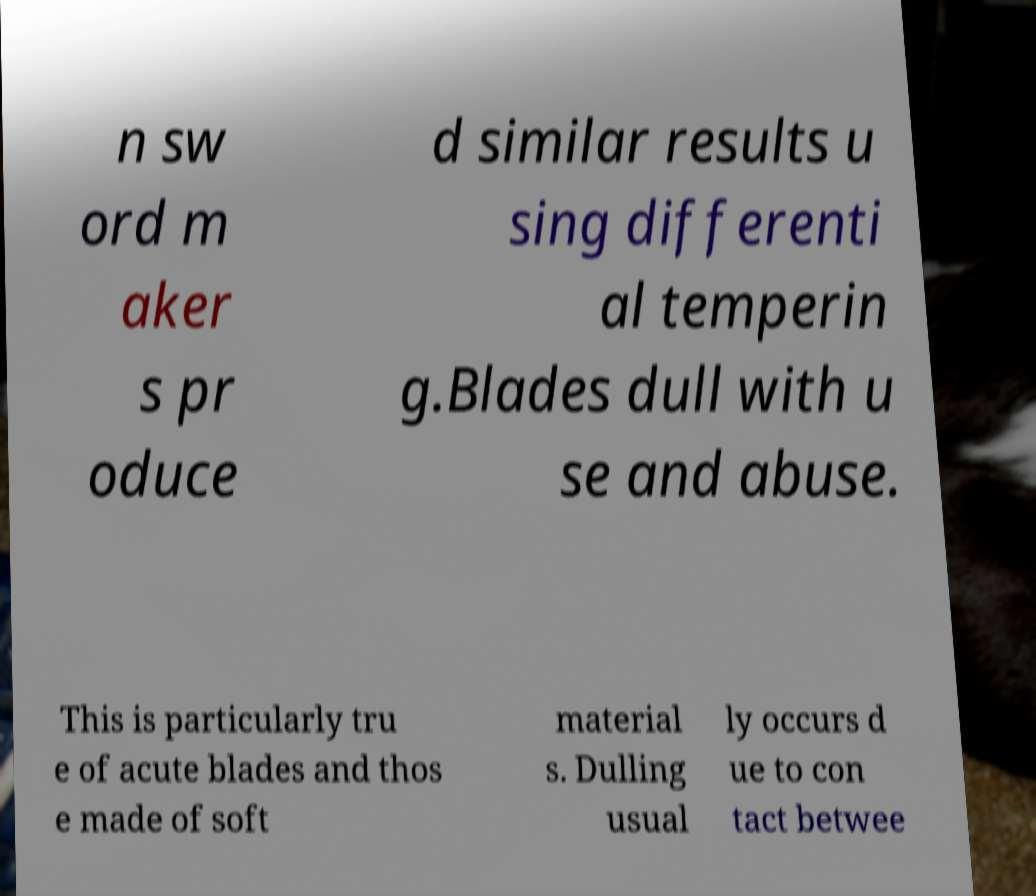Please identify and transcribe the text found in this image. n sw ord m aker s pr oduce d similar results u sing differenti al temperin g.Blades dull with u se and abuse. This is particularly tru e of acute blades and thos e made of soft material s. Dulling usual ly occurs d ue to con tact betwee 